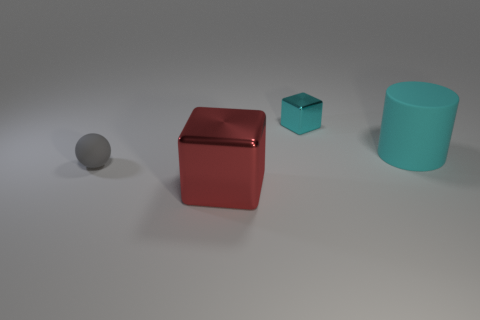Add 3 big red metallic objects. How many objects exist? 7 Subtract all balls. How many objects are left? 3 Add 4 big red cubes. How many big red cubes exist? 5 Subtract 0 yellow balls. How many objects are left? 4 Subtract all small rubber things. Subtract all large objects. How many objects are left? 1 Add 1 cylinders. How many cylinders are left? 2 